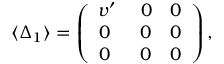<formula> <loc_0><loc_0><loc_500><loc_500>\langle \Delta _ { 1 } \rangle = \left ( \begin{array} { c } { { v ^ { \prime } \quad \ 0 \quad 0 } } \\ { 0 \ \quad \ 0 \quad 0 } \\ { 0 \ \quad \ 0 \quad 0 } \end{array} \right ) ,</formula> 